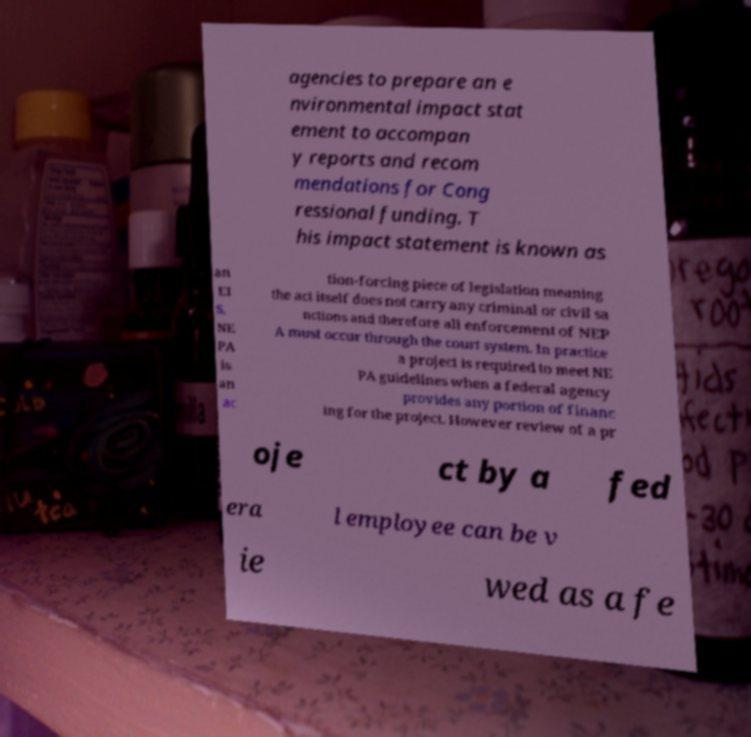There's text embedded in this image that I need extracted. Can you transcribe it verbatim? agencies to prepare an e nvironmental impact stat ement to accompan y reports and recom mendations for Cong ressional funding. T his impact statement is known as an EI S. NE PA is an ac tion-forcing piece of legislation meaning the act itself does not carry any criminal or civil sa nctions and therefore all enforcement of NEP A must occur through the court system. In practice a project is required to meet NE PA guidelines when a federal agency provides any portion of financ ing for the project. However review of a pr oje ct by a fed era l employee can be v ie wed as a fe 